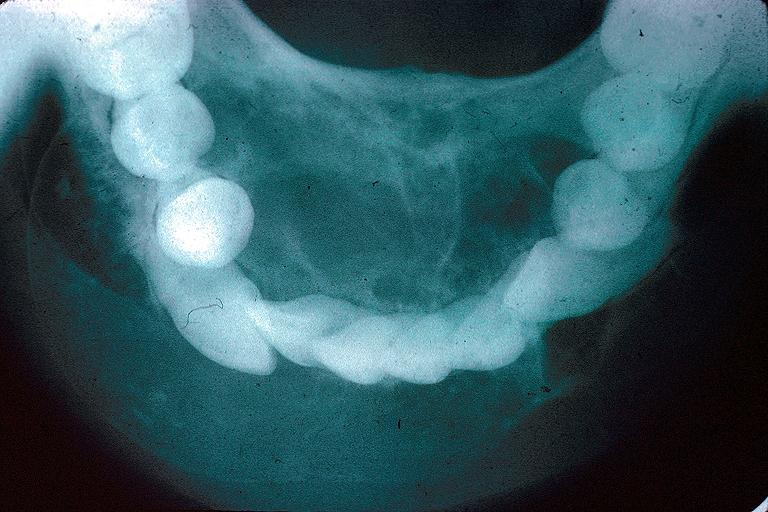what does this image show?
Answer the question using a single word or phrase. Odontogenic myxoma 